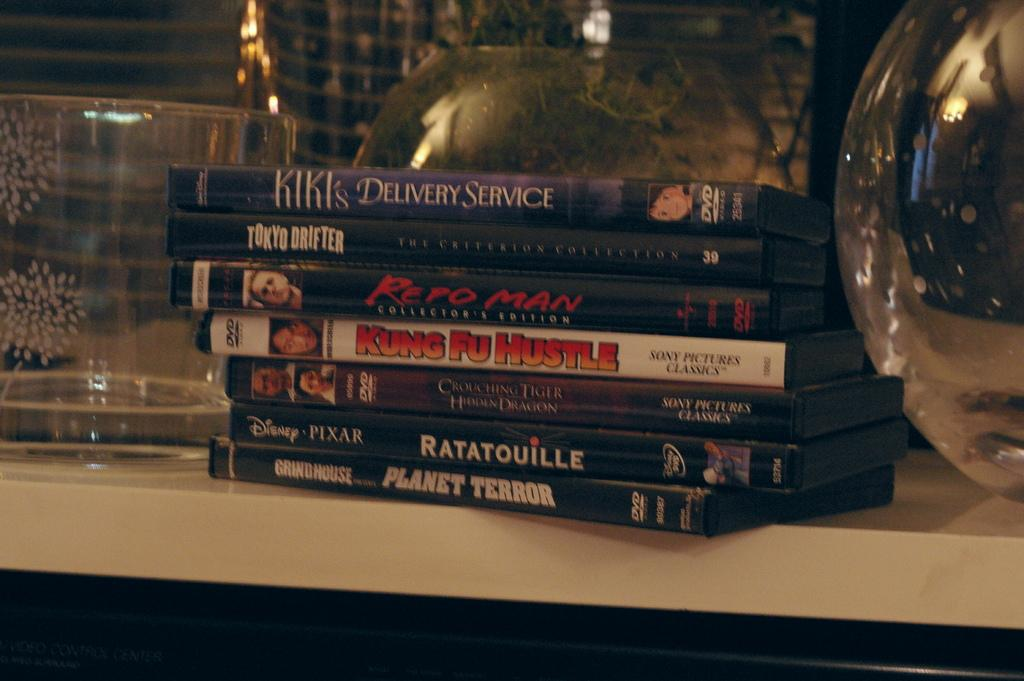<image>
Give a short and clear explanation of the subsequent image. A stack of DVDs sit on a shelf an dinclude Ratatouille, Planet Terror, and Kung Fu Hustle. 